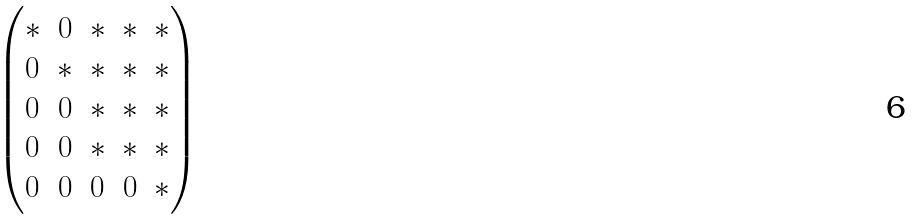Convert formula to latex. <formula><loc_0><loc_0><loc_500><loc_500>\begin{pmatrix} * & 0 & * & * & * \\ 0 & * & * & * & * \\ 0 & 0 & * & * & * \\ 0 & 0 & * & * & * \\ 0 & 0 & 0 & 0 & * \\ \end{pmatrix}</formula> 